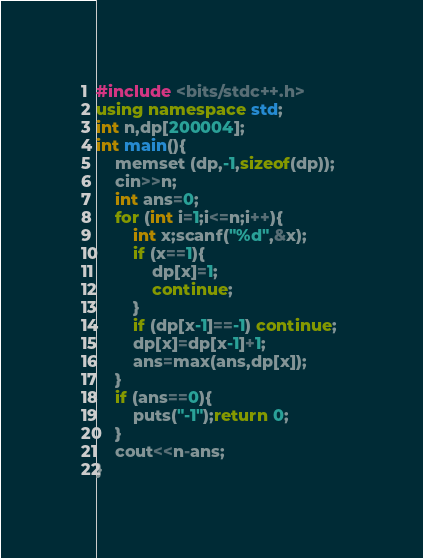Convert code to text. <code><loc_0><loc_0><loc_500><loc_500><_C++_>#include <bits/stdc++.h>
using namespace std;
int n,dp[200004];
int main(){
	memset (dp,-1,sizeof(dp));
	cin>>n;
	int ans=0;
	for (int i=1;i<=n;i++){
		int x;scanf("%d",&x);
		if (x==1){
			dp[x]=1;
			continue;
		}
		if (dp[x-1]==-1) continue; 
		dp[x]=dp[x-1]+1;
		ans=max(ans,dp[x]);
	}
	if (ans==0){
		puts("-1");return 0;
	}
	cout<<n-ans;
}</code> 